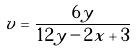<formula> <loc_0><loc_0><loc_500><loc_500>v = \frac { 6 y } { 1 2 y - 2 x + 3 }</formula> 